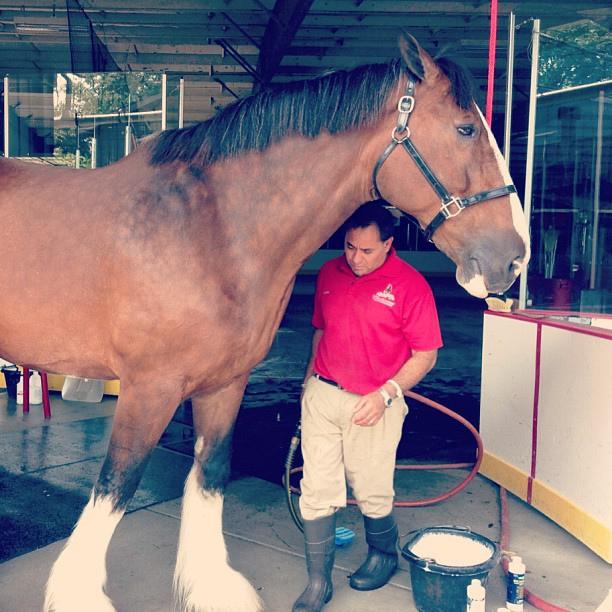Is the man holding a hose?
Give a very brief answer. Yes. What is the man wearing on his feet?
Short answer required. Boots. Is this horse larger than life?
Be succinct. Yes. 